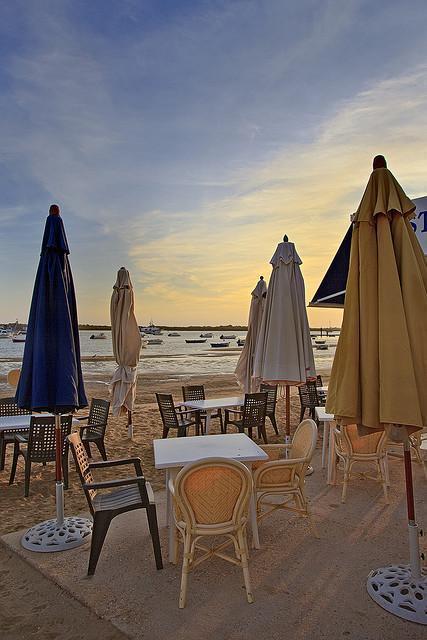What is near the table?
Answer the question by selecting the correct answer among the 4 following choices.
Options: Cow, baby, cat, chair. Chair. 